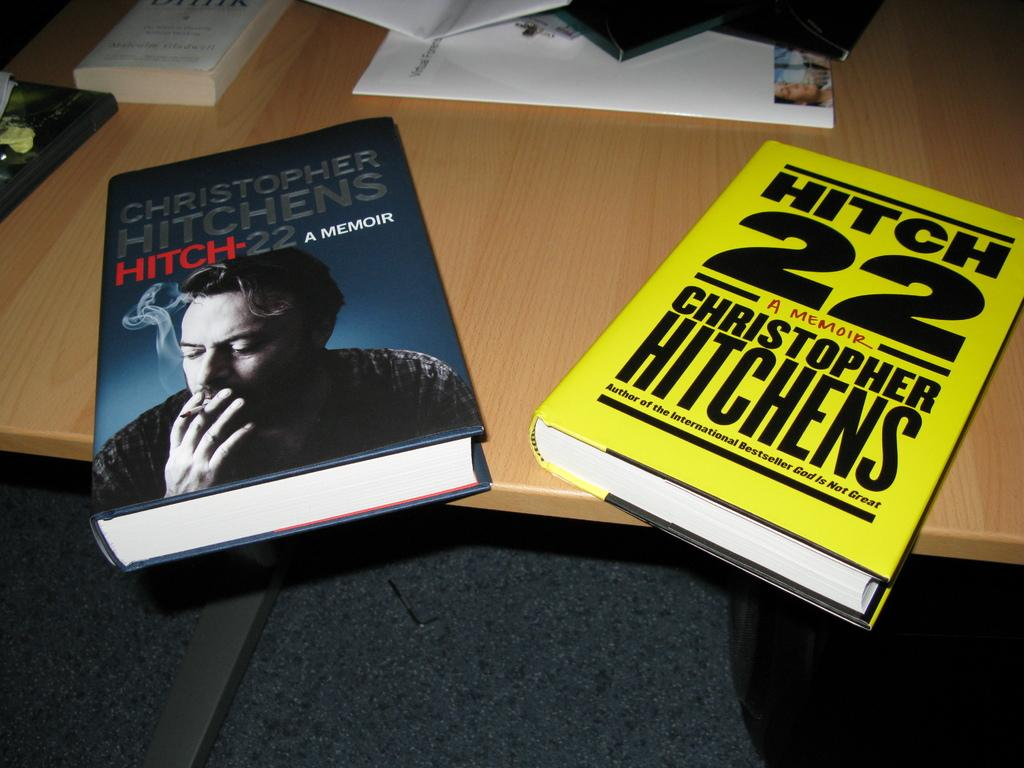<image>
Present a compact description of the photo's key features. Yellow book that says the number 22 on it. 